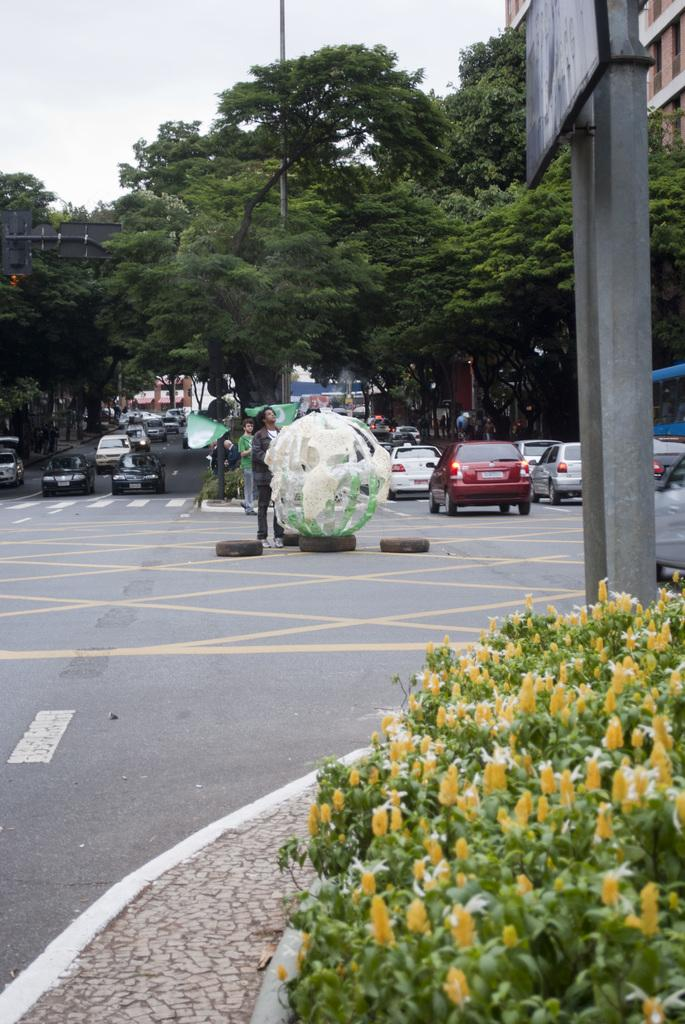What types of objects can be seen in the image? There are vehicles, people, trees, poles, boards, and objects on the ground visible in the image. What is the ground surface like in the image? The ground is visible in the image, but there is no specific detail about its surface. What type of vegetation is present in the image? There are trees and plants visible in the image. What is visible in the background of the image? The sky is visible in the image. How does the growth of the trees affect the order of the vehicles in the image? The growth of the trees does not affect the order of the vehicles in the image, as there is no indication of any interaction between the trees and vehicles. What type of cover is provided by the objects on the ground in the image? There is no information about any cover provided by the objects on the ground in the image. 